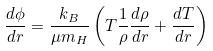Convert formula to latex. <formula><loc_0><loc_0><loc_500><loc_500>\frac { d \phi } { d r } = \frac { k _ { B } } { \mu m _ { H } } \left ( T \frac { 1 } { \rho } \frac { d \rho } { d r } + \frac { d T } { d r } \right )</formula> 